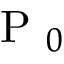<formula> <loc_0><loc_0><loc_500><loc_500>P _ { 0 }</formula> 